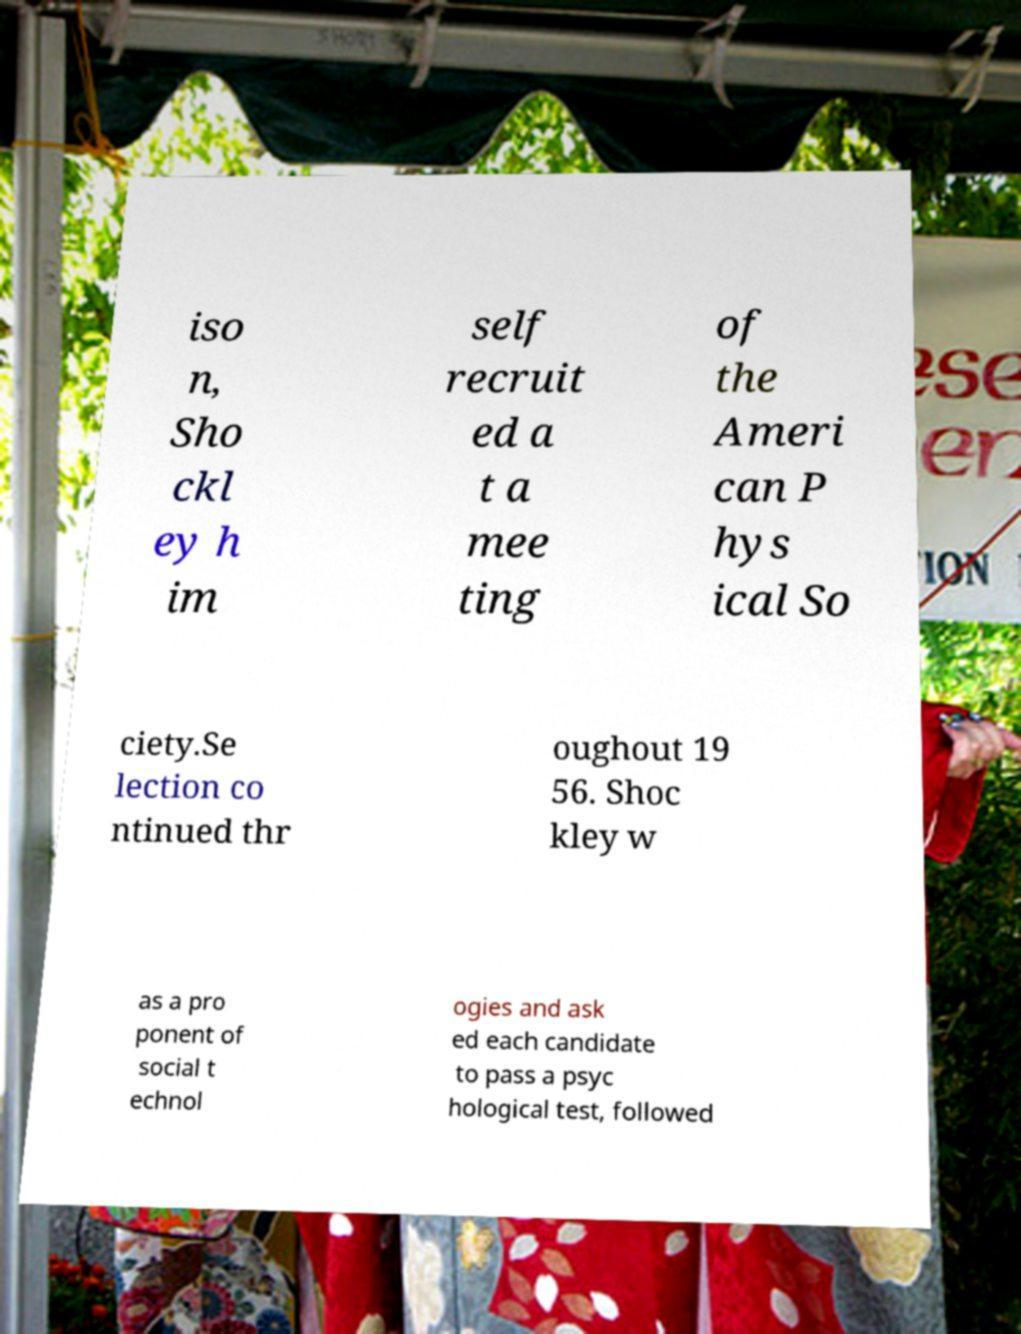Could you assist in decoding the text presented in this image and type it out clearly? iso n, Sho ckl ey h im self recruit ed a t a mee ting of the Ameri can P hys ical So ciety.Se lection co ntinued thr oughout 19 56. Shoc kley w as a pro ponent of social t echnol ogies and ask ed each candidate to pass a psyc hological test, followed 